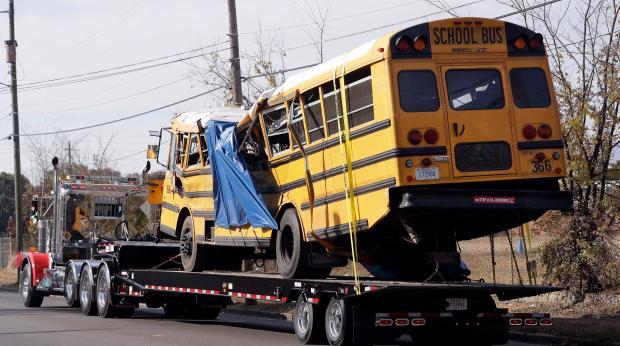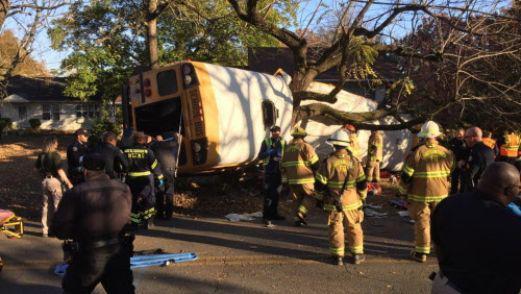The first image is the image on the left, the second image is the image on the right. Analyze the images presented: Is the assertion "Each image shows a yellow school bus which has been damaged in an accident." valid? Answer yes or no. Yes. The first image is the image on the left, the second image is the image on the right. Examine the images to the left and right. Is the description "The school bus door is open and ready to accept passengers." accurate? Answer yes or no. No. 